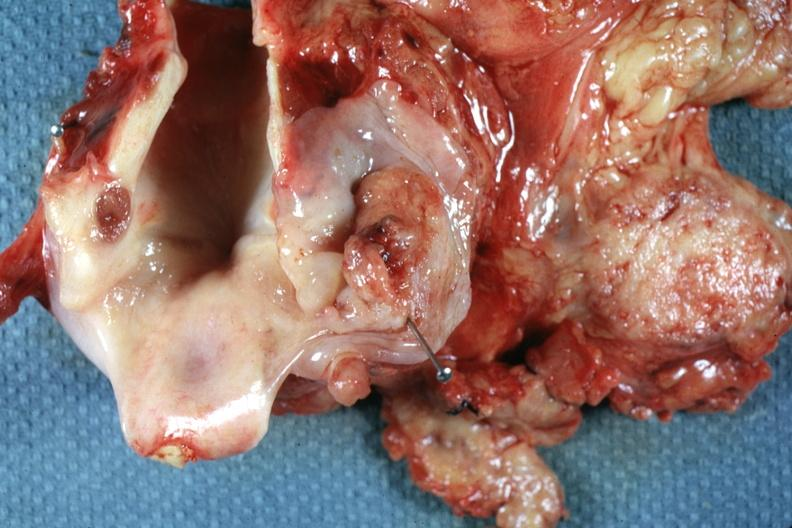what is present?
Answer the question using a single word or phrase. Squamous cell carcinoma 